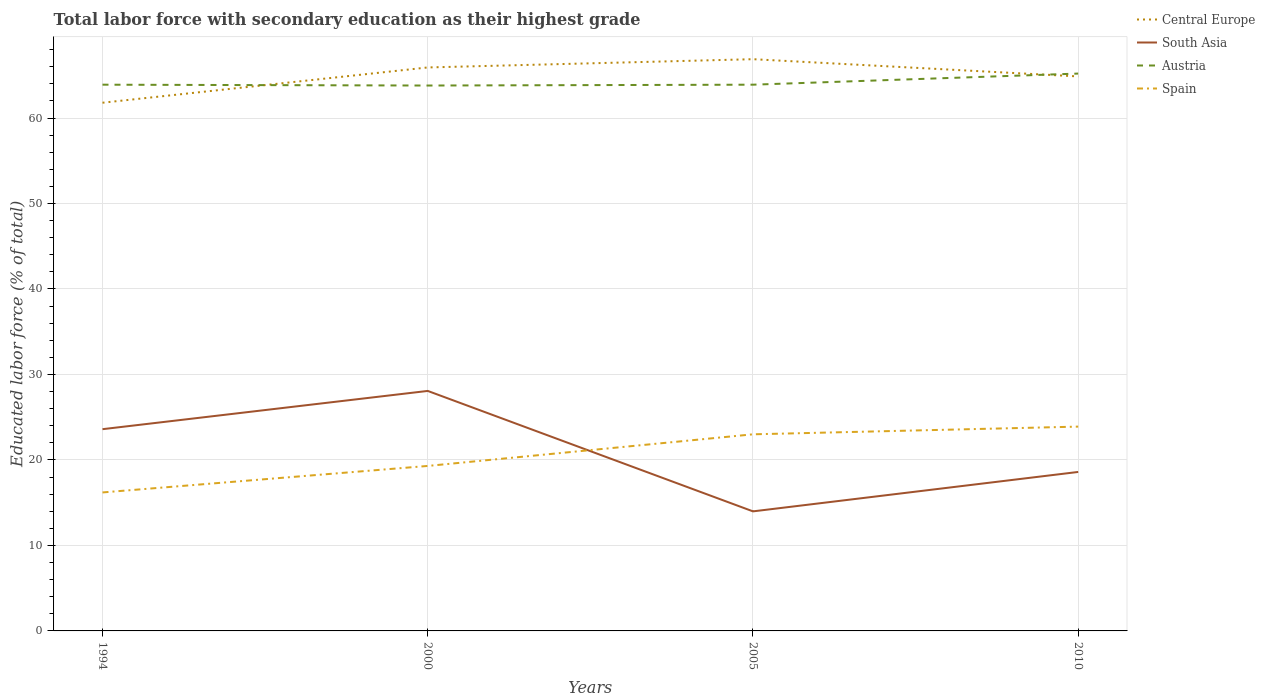Across all years, what is the maximum percentage of total labor force with primary education in South Asia?
Your answer should be compact. 13.99. What is the total percentage of total labor force with primary education in Central Europe in the graph?
Ensure brevity in your answer.  -0.97. What is the difference between the highest and the second highest percentage of total labor force with primary education in South Asia?
Provide a short and direct response. 14.09. What is the difference between the highest and the lowest percentage of total labor force with primary education in South Asia?
Ensure brevity in your answer.  2. Is the percentage of total labor force with primary education in Spain strictly greater than the percentage of total labor force with primary education in Central Europe over the years?
Keep it short and to the point. Yes. What is the difference between two consecutive major ticks on the Y-axis?
Keep it short and to the point. 10. Are the values on the major ticks of Y-axis written in scientific E-notation?
Keep it short and to the point. No. Does the graph contain any zero values?
Keep it short and to the point. No. Where does the legend appear in the graph?
Offer a very short reply. Top right. How many legend labels are there?
Provide a succinct answer. 4. What is the title of the graph?
Ensure brevity in your answer.  Total labor force with secondary education as their highest grade. Does "Kazakhstan" appear as one of the legend labels in the graph?
Offer a very short reply. No. What is the label or title of the X-axis?
Your response must be concise. Years. What is the label or title of the Y-axis?
Provide a succinct answer. Educated labor force (% of total). What is the Educated labor force (% of total) of Central Europe in 1994?
Ensure brevity in your answer.  61.79. What is the Educated labor force (% of total) in South Asia in 1994?
Provide a succinct answer. 23.6. What is the Educated labor force (% of total) of Austria in 1994?
Your answer should be compact. 63.9. What is the Educated labor force (% of total) in Spain in 1994?
Make the answer very short. 16.2. What is the Educated labor force (% of total) in Central Europe in 2000?
Your answer should be very brief. 65.91. What is the Educated labor force (% of total) in South Asia in 2000?
Ensure brevity in your answer.  28.08. What is the Educated labor force (% of total) in Austria in 2000?
Your response must be concise. 63.8. What is the Educated labor force (% of total) in Spain in 2000?
Make the answer very short. 19.3. What is the Educated labor force (% of total) of Central Europe in 2005?
Offer a terse response. 66.88. What is the Educated labor force (% of total) in South Asia in 2005?
Your response must be concise. 13.99. What is the Educated labor force (% of total) of Austria in 2005?
Offer a terse response. 63.9. What is the Educated labor force (% of total) in Central Europe in 2010?
Offer a terse response. 64.87. What is the Educated labor force (% of total) in South Asia in 2010?
Give a very brief answer. 18.6. What is the Educated labor force (% of total) in Austria in 2010?
Ensure brevity in your answer.  65.2. What is the Educated labor force (% of total) of Spain in 2010?
Your answer should be compact. 23.9. Across all years, what is the maximum Educated labor force (% of total) in Central Europe?
Provide a succinct answer. 66.88. Across all years, what is the maximum Educated labor force (% of total) in South Asia?
Make the answer very short. 28.08. Across all years, what is the maximum Educated labor force (% of total) in Austria?
Keep it short and to the point. 65.2. Across all years, what is the maximum Educated labor force (% of total) in Spain?
Your response must be concise. 23.9. Across all years, what is the minimum Educated labor force (% of total) of Central Europe?
Keep it short and to the point. 61.79. Across all years, what is the minimum Educated labor force (% of total) in South Asia?
Keep it short and to the point. 13.99. Across all years, what is the minimum Educated labor force (% of total) in Austria?
Give a very brief answer. 63.8. Across all years, what is the minimum Educated labor force (% of total) in Spain?
Offer a very short reply. 16.2. What is the total Educated labor force (% of total) of Central Europe in the graph?
Offer a very short reply. 259.45. What is the total Educated labor force (% of total) in South Asia in the graph?
Your answer should be very brief. 84.26. What is the total Educated labor force (% of total) in Austria in the graph?
Offer a very short reply. 256.8. What is the total Educated labor force (% of total) of Spain in the graph?
Make the answer very short. 82.4. What is the difference between the Educated labor force (% of total) of Central Europe in 1994 and that in 2000?
Keep it short and to the point. -4.13. What is the difference between the Educated labor force (% of total) of South Asia in 1994 and that in 2000?
Keep it short and to the point. -4.48. What is the difference between the Educated labor force (% of total) of Austria in 1994 and that in 2000?
Offer a very short reply. 0.1. What is the difference between the Educated labor force (% of total) of Spain in 1994 and that in 2000?
Make the answer very short. -3.1. What is the difference between the Educated labor force (% of total) in Central Europe in 1994 and that in 2005?
Make the answer very short. -5.09. What is the difference between the Educated labor force (% of total) in South Asia in 1994 and that in 2005?
Offer a very short reply. 9.61. What is the difference between the Educated labor force (% of total) of Austria in 1994 and that in 2005?
Give a very brief answer. 0. What is the difference between the Educated labor force (% of total) in Central Europe in 1994 and that in 2010?
Provide a short and direct response. -3.08. What is the difference between the Educated labor force (% of total) in South Asia in 1994 and that in 2010?
Offer a terse response. 5. What is the difference between the Educated labor force (% of total) in Austria in 1994 and that in 2010?
Provide a succinct answer. -1.3. What is the difference between the Educated labor force (% of total) of Spain in 1994 and that in 2010?
Keep it short and to the point. -7.7. What is the difference between the Educated labor force (% of total) in Central Europe in 2000 and that in 2005?
Keep it short and to the point. -0.97. What is the difference between the Educated labor force (% of total) in South Asia in 2000 and that in 2005?
Keep it short and to the point. 14.09. What is the difference between the Educated labor force (% of total) in Spain in 2000 and that in 2005?
Your answer should be compact. -3.7. What is the difference between the Educated labor force (% of total) in Central Europe in 2000 and that in 2010?
Your answer should be very brief. 1.05. What is the difference between the Educated labor force (% of total) in South Asia in 2000 and that in 2010?
Your answer should be compact. 9.48. What is the difference between the Educated labor force (% of total) of Spain in 2000 and that in 2010?
Keep it short and to the point. -4.6. What is the difference between the Educated labor force (% of total) in Central Europe in 2005 and that in 2010?
Offer a terse response. 2.02. What is the difference between the Educated labor force (% of total) in South Asia in 2005 and that in 2010?
Keep it short and to the point. -4.61. What is the difference between the Educated labor force (% of total) of Central Europe in 1994 and the Educated labor force (% of total) of South Asia in 2000?
Make the answer very short. 33.71. What is the difference between the Educated labor force (% of total) of Central Europe in 1994 and the Educated labor force (% of total) of Austria in 2000?
Your answer should be compact. -2.01. What is the difference between the Educated labor force (% of total) in Central Europe in 1994 and the Educated labor force (% of total) in Spain in 2000?
Offer a very short reply. 42.49. What is the difference between the Educated labor force (% of total) of South Asia in 1994 and the Educated labor force (% of total) of Austria in 2000?
Ensure brevity in your answer.  -40.2. What is the difference between the Educated labor force (% of total) of Austria in 1994 and the Educated labor force (% of total) of Spain in 2000?
Provide a succinct answer. 44.6. What is the difference between the Educated labor force (% of total) in Central Europe in 1994 and the Educated labor force (% of total) in South Asia in 2005?
Offer a very short reply. 47.8. What is the difference between the Educated labor force (% of total) of Central Europe in 1994 and the Educated labor force (% of total) of Austria in 2005?
Ensure brevity in your answer.  -2.11. What is the difference between the Educated labor force (% of total) of Central Europe in 1994 and the Educated labor force (% of total) of Spain in 2005?
Provide a short and direct response. 38.79. What is the difference between the Educated labor force (% of total) in South Asia in 1994 and the Educated labor force (% of total) in Austria in 2005?
Your response must be concise. -40.3. What is the difference between the Educated labor force (% of total) of Austria in 1994 and the Educated labor force (% of total) of Spain in 2005?
Your response must be concise. 40.9. What is the difference between the Educated labor force (% of total) of Central Europe in 1994 and the Educated labor force (% of total) of South Asia in 2010?
Give a very brief answer. 43.19. What is the difference between the Educated labor force (% of total) of Central Europe in 1994 and the Educated labor force (% of total) of Austria in 2010?
Offer a terse response. -3.41. What is the difference between the Educated labor force (% of total) of Central Europe in 1994 and the Educated labor force (% of total) of Spain in 2010?
Offer a terse response. 37.89. What is the difference between the Educated labor force (% of total) in South Asia in 1994 and the Educated labor force (% of total) in Austria in 2010?
Offer a terse response. -41.6. What is the difference between the Educated labor force (% of total) in South Asia in 1994 and the Educated labor force (% of total) in Spain in 2010?
Your answer should be compact. -0.3. What is the difference between the Educated labor force (% of total) in Austria in 1994 and the Educated labor force (% of total) in Spain in 2010?
Offer a very short reply. 40. What is the difference between the Educated labor force (% of total) of Central Europe in 2000 and the Educated labor force (% of total) of South Asia in 2005?
Keep it short and to the point. 51.93. What is the difference between the Educated labor force (% of total) in Central Europe in 2000 and the Educated labor force (% of total) in Austria in 2005?
Your response must be concise. 2.02. What is the difference between the Educated labor force (% of total) of Central Europe in 2000 and the Educated labor force (% of total) of Spain in 2005?
Provide a succinct answer. 42.91. What is the difference between the Educated labor force (% of total) in South Asia in 2000 and the Educated labor force (% of total) in Austria in 2005?
Make the answer very short. -35.82. What is the difference between the Educated labor force (% of total) in South Asia in 2000 and the Educated labor force (% of total) in Spain in 2005?
Your response must be concise. 5.08. What is the difference between the Educated labor force (% of total) of Austria in 2000 and the Educated labor force (% of total) of Spain in 2005?
Make the answer very short. 40.8. What is the difference between the Educated labor force (% of total) of Central Europe in 2000 and the Educated labor force (% of total) of South Asia in 2010?
Offer a very short reply. 47.32. What is the difference between the Educated labor force (% of total) in Central Europe in 2000 and the Educated labor force (% of total) in Austria in 2010?
Provide a short and direct response. 0.71. What is the difference between the Educated labor force (% of total) of Central Europe in 2000 and the Educated labor force (% of total) of Spain in 2010?
Provide a succinct answer. 42.02. What is the difference between the Educated labor force (% of total) in South Asia in 2000 and the Educated labor force (% of total) in Austria in 2010?
Provide a short and direct response. -37.12. What is the difference between the Educated labor force (% of total) in South Asia in 2000 and the Educated labor force (% of total) in Spain in 2010?
Keep it short and to the point. 4.18. What is the difference between the Educated labor force (% of total) in Austria in 2000 and the Educated labor force (% of total) in Spain in 2010?
Offer a very short reply. 39.9. What is the difference between the Educated labor force (% of total) in Central Europe in 2005 and the Educated labor force (% of total) in South Asia in 2010?
Your answer should be very brief. 48.28. What is the difference between the Educated labor force (% of total) of Central Europe in 2005 and the Educated labor force (% of total) of Austria in 2010?
Keep it short and to the point. 1.68. What is the difference between the Educated labor force (% of total) in Central Europe in 2005 and the Educated labor force (% of total) in Spain in 2010?
Provide a short and direct response. 42.98. What is the difference between the Educated labor force (% of total) of South Asia in 2005 and the Educated labor force (% of total) of Austria in 2010?
Your answer should be compact. -51.21. What is the difference between the Educated labor force (% of total) in South Asia in 2005 and the Educated labor force (% of total) in Spain in 2010?
Offer a very short reply. -9.91. What is the average Educated labor force (% of total) in Central Europe per year?
Make the answer very short. 64.86. What is the average Educated labor force (% of total) of South Asia per year?
Offer a very short reply. 21.06. What is the average Educated labor force (% of total) of Austria per year?
Provide a short and direct response. 64.2. What is the average Educated labor force (% of total) of Spain per year?
Provide a succinct answer. 20.6. In the year 1994, what is the difference between the Educated labor force (% of total) of Central Europe and Educated labor force (% of total) of South Asia?
Offer a very short reply. 38.19. In the year 1994, what is the difference between the Educated labor force (% of total) of Central Europe and Educated labor force (% of total) of Austria?
Make the answer very short. -2.11. In the year 1994, what is the difference between the Educated labor force (% of total) of Central Europe and Educated labor force (% of total) of Spain?
Provide a short and direct response. 45.59. In the year 1994, what is the difference between the Educated labor force (% of total) of South Asia and Educated labor force (% of total) of Austria?
Provide a short and direct response. -40.3. In the year 1994, what is the difference between the Educated labor force (% of total) of Austria and Educated labor force (% of total) of Spain?
Offer a very short reply. 47.7. In the year 2000, what is the difference between the Educated labor force (% of total) of Central Europe and Educated labor force (% of total) of South Asia?
Your answer should be very brief. 37.84. In the year 2000, what is the difference between the Educated labor force (% of total) in Central Europe and Educated labor force (% of total) in Austria?
Give a very brief answer. 2.12. In the year 2000, what is the difference between the Educated labor force (% of total) in Central Europe and Educated labor force (% of total) in Spain?
Offer a terse response. 46.62. In the year 2000, what is the difference between the Educated labor force (% of total) in South Asia and Educated labor force (% of total) in Austria?
Provide a short and direct response. -35.72. In the year 2000, what is the difference between the Educated labor force (% of total) in South Asia and Educated labor force (% of total) in Spain?
Keep it short and to the point. 8.78. In the year 2000, what is the difference between the Educated labor force (% of total) of Austria and Educated labor force (% of total) of Spain?
Your answer should be very brief. 44.5. In the year 2005, what is the difference between the Educated labor force (% of total) in Central Europe and Educated labor force (% of total) in South Asia?
Your answer should be very brief. 52.9. In the year 2005, what is the difference between the Educated labor force (% of total) in Central Europe and Educated labor force (% of total) in Austria?
Offer a very short reply. 2.98. In the year 2005, what is the difference between the Educated labor force (% of total) in Central Europe and Educated labor force (% of total) in Spain?
Make the answer very short. 43.88. In the year 2005, what is the difference between the Educated labor force (% of total) of South Asia and Educated labor force (% of total) of Austria?
Provide a succinct answer. -49.91. In the year 2005, what is the difference between the Educated labor force (% of total) in South Asia and Educated labor force (% of total) in Spain?
Your response must be concise. -9.01. In the year 2005, what is the difference between the Educated labor force (% of total) of Austria and Educated labor force (% of total) of Spain?
Provide a short and direct response. 40.9. In the year 2010, what is the difference between the Educated labor force (% of total) in Central Europe and Educated labor force (% of total) in South Asia?
Make the answer very short. 46.27. In the year 2010, what is the difference between the Educated labor force (% of total) of Central Europe and Educated labor force (% of total) of Austria?
Keep it short and to the point. -0.33. In the year 2010, what is the difference between the Educated labor force (% of total) of Central Europe and Educated labor force (% of total) of Spain?
Offer a very short reply. 40.97. In the year 2010, what is the difference between the Educated labor force (% of total) in South Asia and Educated labor force (% of total) in Austria?
Provide a short and direct response. -46.6. In the year 2010, what is the difference between the Educated labor force (% of total) of South Asia and Educated labor force (% of total) of Spain?
Ensure brevity in your answer.  -5.3. In the year 2010, what is the difference between the Educated labor force (% of total) in Austria and Educated labor force (% of total) in Spain?
Your answer should be very brief. 41.3. What is the ratio of the Educated labor force (% of total) of Central Europe in 1994 to that in 2000?
Provide a succinct answer. 0.94. What is the ratio of the Educated labor force (% of total) in South Asia in 1994 to that in 2000?
Provide a short and direct response. 0.84. What is the ratio of the Educated labor force (% of total) in Austria in 1994 to that in 2000?
Provide a succinct answer. 1. What is the ratio of the Educated labor force (% of total) in Spain in 1994 to that in 2000?
Give a very brief answer. 0.84. What is the ratio of the Educated labor force (% of total) of Central Europe in 1994 to that in 2005?
Your answer should be very brief. 0.92. What is the ratio of the Educated labor force (% of total) of South Asia in 1994 to that in 2005?
Ensure brevity in your answer.  1.69. What is the ratio of the Educated labor force (% of total) of Spain in 1994 to that in 2005?
Ensure brevity in your answer.  0.7. What is the ratio of the Educated labor force (% of total) of Central Europe in 1994 to that in 2010?
Your answer should be very brief. 0.95. What is the ratio of the Educated labor force (% of total) of South Asia in 1994 to that in 2010?
Provide a short and direct response. 1.27. What is the ratio of the Educated labor force (% of total) of Austria in 1994 to that in 2010?
Offer a terse response. 0.98. What is the ratio of the Educated labor force (% of total) in Spain in 1994 to that in 2010?
Give a very brief answer. 0.68. What is the ratio of the Educated labor force (% of total) of Central Europe in 2000 to that in 2005?
Provide a short and direct response. 0.99. What is the ratio of the Educated labor force (% of total) of South Asia in 2000 to that in 2005?
Offer a very short reply. 2.01. What is the ratio of the Educated labor force (% of total) of Austria in 2000 to that in 2005?
Offer a very short reply. 1. What is the ratio of the Educated labor force (% of total) in Spain in 2000 to that in 2005?
Provide a succinct answer. 0.84. What is the ratio of the Educated labor force (% of total) in Central Europe in 2000 to that in 2010?
Offer a terse response. 1.02. What is the ratio of the Educated labor force (% of total) of South Asia in 2000 to that in 2010?
Make the answer very short. 1.51. What is the ratio of the Educated labor force (% of total) in Austria in 2000 to that in 2010?
Provide a short and direct response. 0.98. What is the ratio of the Educated labor force (% of total) of Spain in 2000 to that in 2010?
Offer a very short reply. 0.81. What is the ratio of the Educated labor force (% of total) of Central Europe in 2005 to that in 2010?
Make the answer very short. 1.03. What is the ratio of the Educated labor force (% of total) of South Asia in 2005 to that in 2010?
Provide a short and direct response. 0.75. What is the ratio of the Educated labor force (% of total) in Austria in 2005 to that in 2010?
Make the answer very short. 0.98. What is the ratio of the Educated labor force (% of total) of Spain in 2005 to that in 2010?
Provide a succinct answer. 0.96. What is the difference between the highest and the second highest Educated labor force (% of total) in Central Europe?
Provide a short and direct response. 0.97. What is the difference between the highest and the second highest Educated labor force (% of total) of South Asia?
Provide a short and direct response. 4.48. What is the difference between the highest and the second highest Educated labor force (% of total) of Spain?
Offer a very short reply. 0.9. What is the difference between the highest and the lowest Educated labor force (% of total) of Central Europe?
Your response must be concise. 5.09. What is the difference between the highest and the lowest Educated labor force (% of total) of South Asia?
Keep it short and to the point. 14.09. What is the difference between the highest and the lowest Educated labor force (% of total) of Austria?
Give a very brief answer. 1.4. 